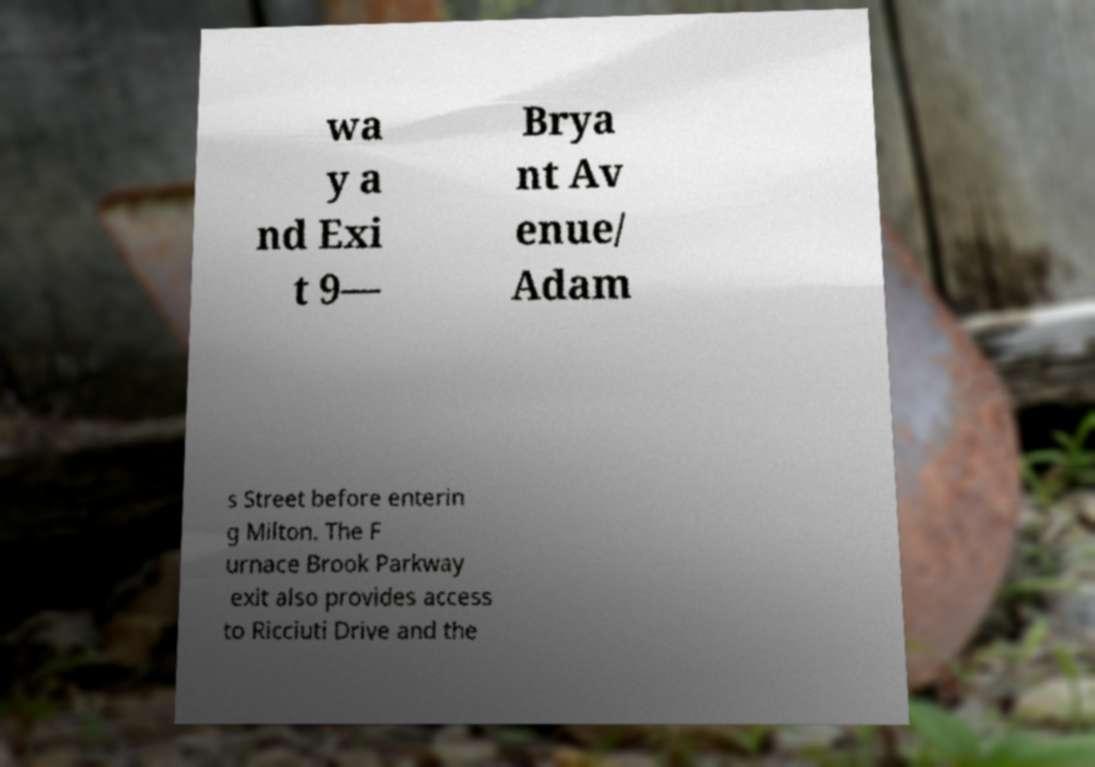What messages or text are displayed in this image? I need them in a readable, typed format. wa y a nd Exi t 9— Brya nt Av enue/ Adam s Street before enterin g Milton. The F urnace Brook Parkway exit also provides access to Ricciuti Drive and the 